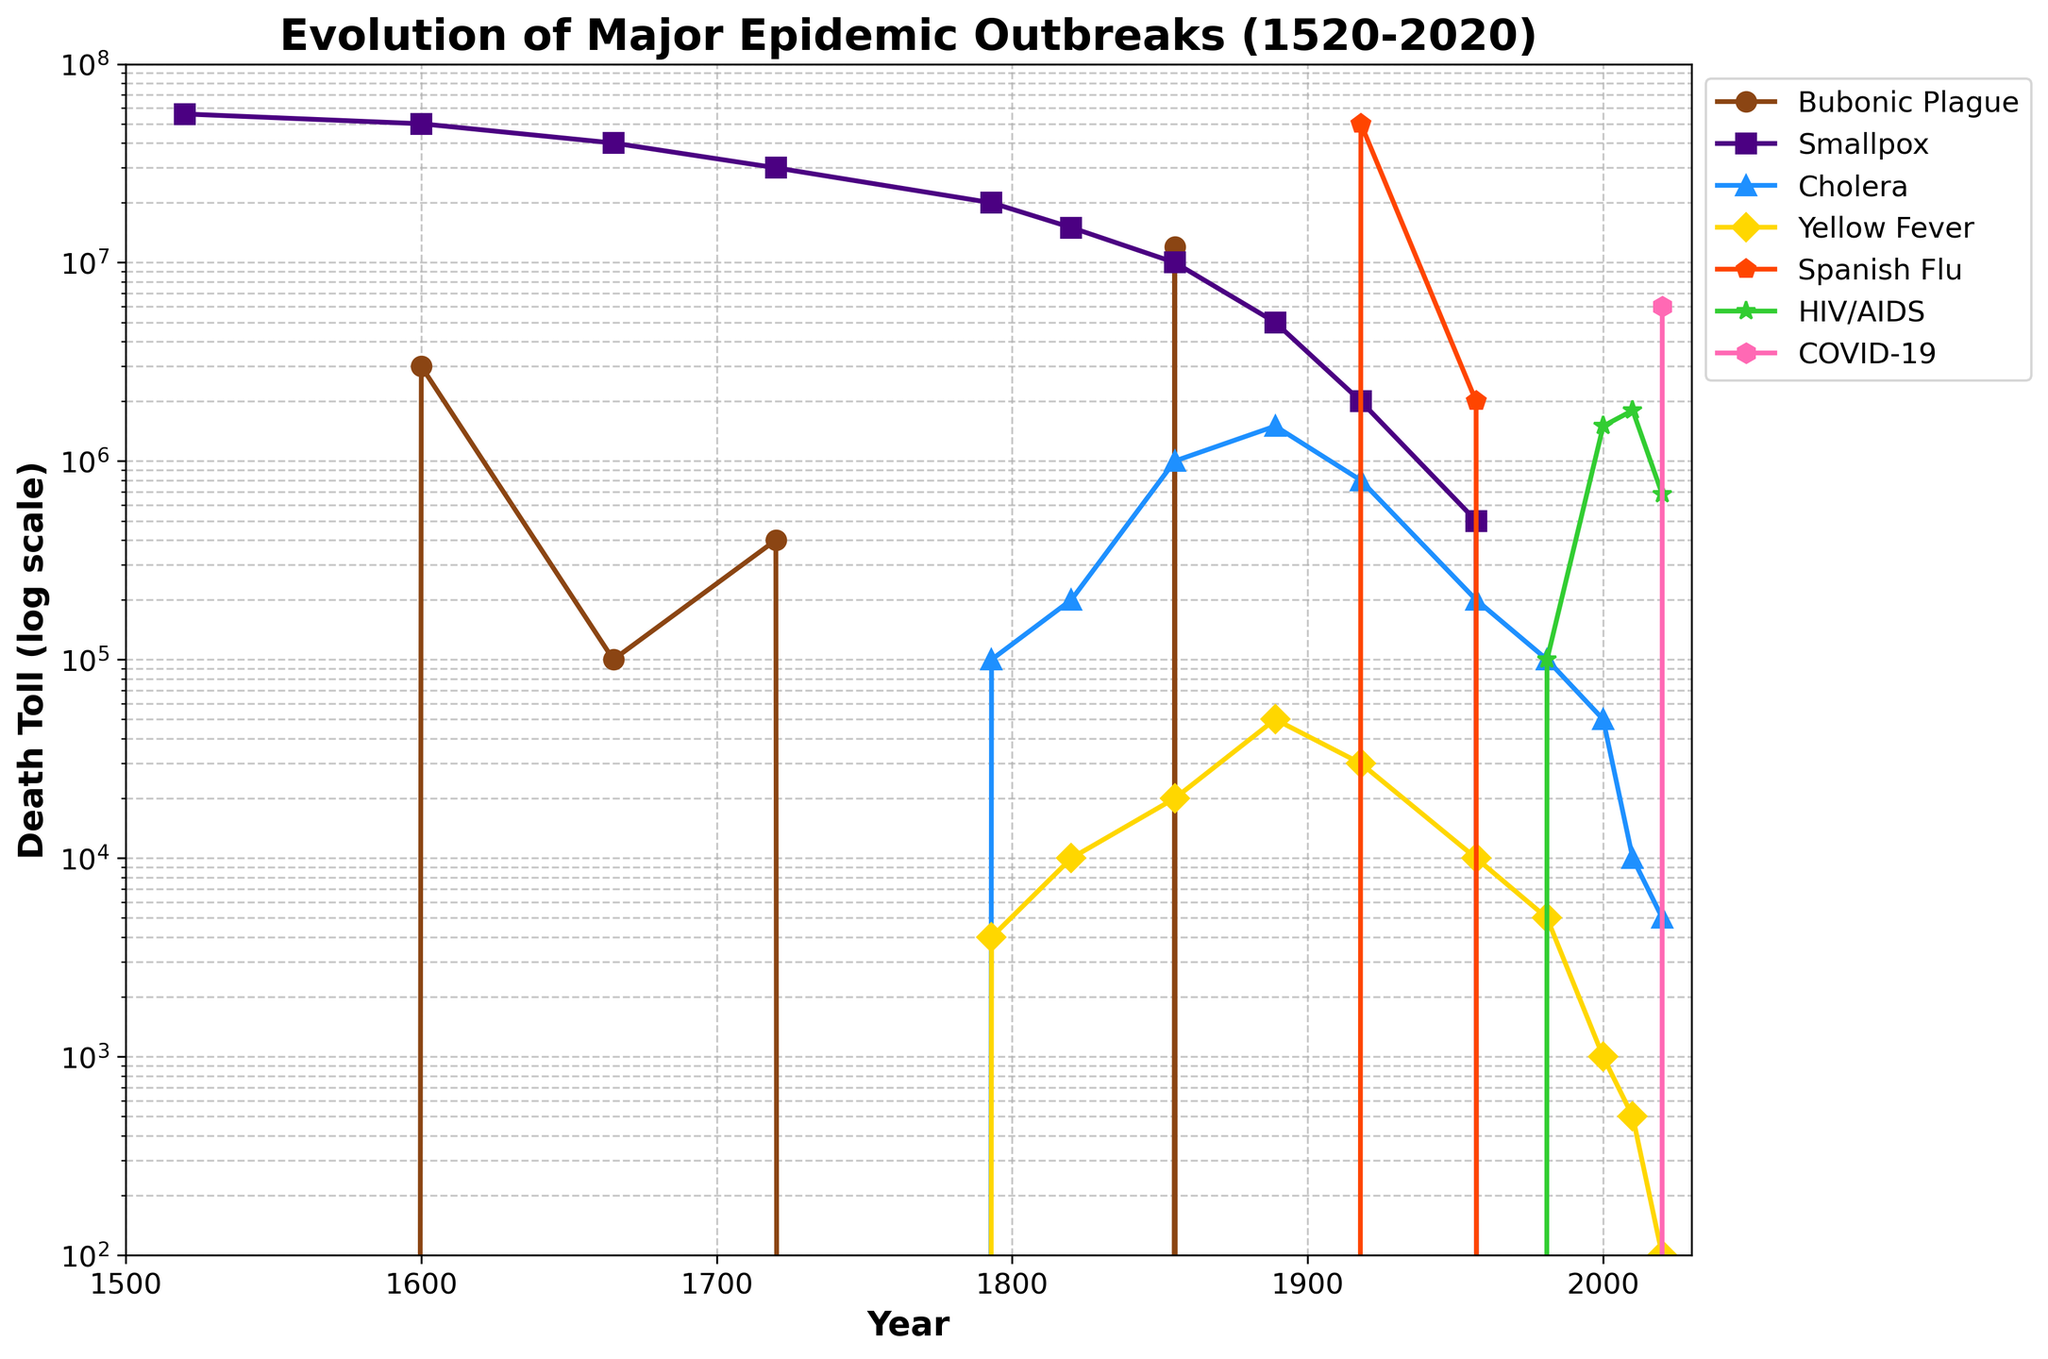What epidemic had the highest death toll in 1520? The figure shows the death toll for several epidemics over the years. Look at the year 1520 and identify the epidemic with the highest data point.
Answer: Smallpox Which epidemic had a higher death toll in 1918, Spanish Flu or Smallpox? Compare the data points for Spanish Flu and Smallpox for the year 1918. The Spanish Flu's death toll is higher.
Answer: Spanish Flu What was the death toll of the Bubonic Plague in 1855? Locate the data point on the Bubonic Plague's line chart for the year 1855.
Answer: 12,000,000 How does the death toll of COVID-19 in 2020 compare to that of HIV/AIDS in 2020? Compare the data points of COVID-19 and HIV/AIDS for the year 2020. The death toll for COVID-19 is higher.
Answer: COVID-19 is higher Did any epidemic have a death toll greater than 10 million in 1793? Check the data points for all epidemics in the year 1793. None exceed 10 million.
Answer: No Estimate the period with the highest increase in death toll for Cholera. Look at the trend line for Cholera and find the period where the slope of increase is steepest, particularly between 1820 and 1855.
Answer: 1820-1855 What is the difference between the death toll of Smallpox in 1665 and 1600? Subtract the death toll of Smallpox in 1600 from the death toll in 1665.
Answer: 10,000,000 Which epidemic shows a significant increase in the death toll after 1957? Identify the epidemic whose line shows a sharp increase post-1957. HIV/AIDS shows significant rise.
Answer: HIV/AIDS What is the combined death toll of Yellow Fever in 1855 and Cholera in 1855? Add the death toll of Yellow Fever and Cholera in the year 1855.
Answer: 1,020,000 Which epidemic had a declining death toll between 1720 and 1793? Look at the death toll trends for each disease between 1720 and 1793. Smallpox shows a decline.
Answer: Smallpox 